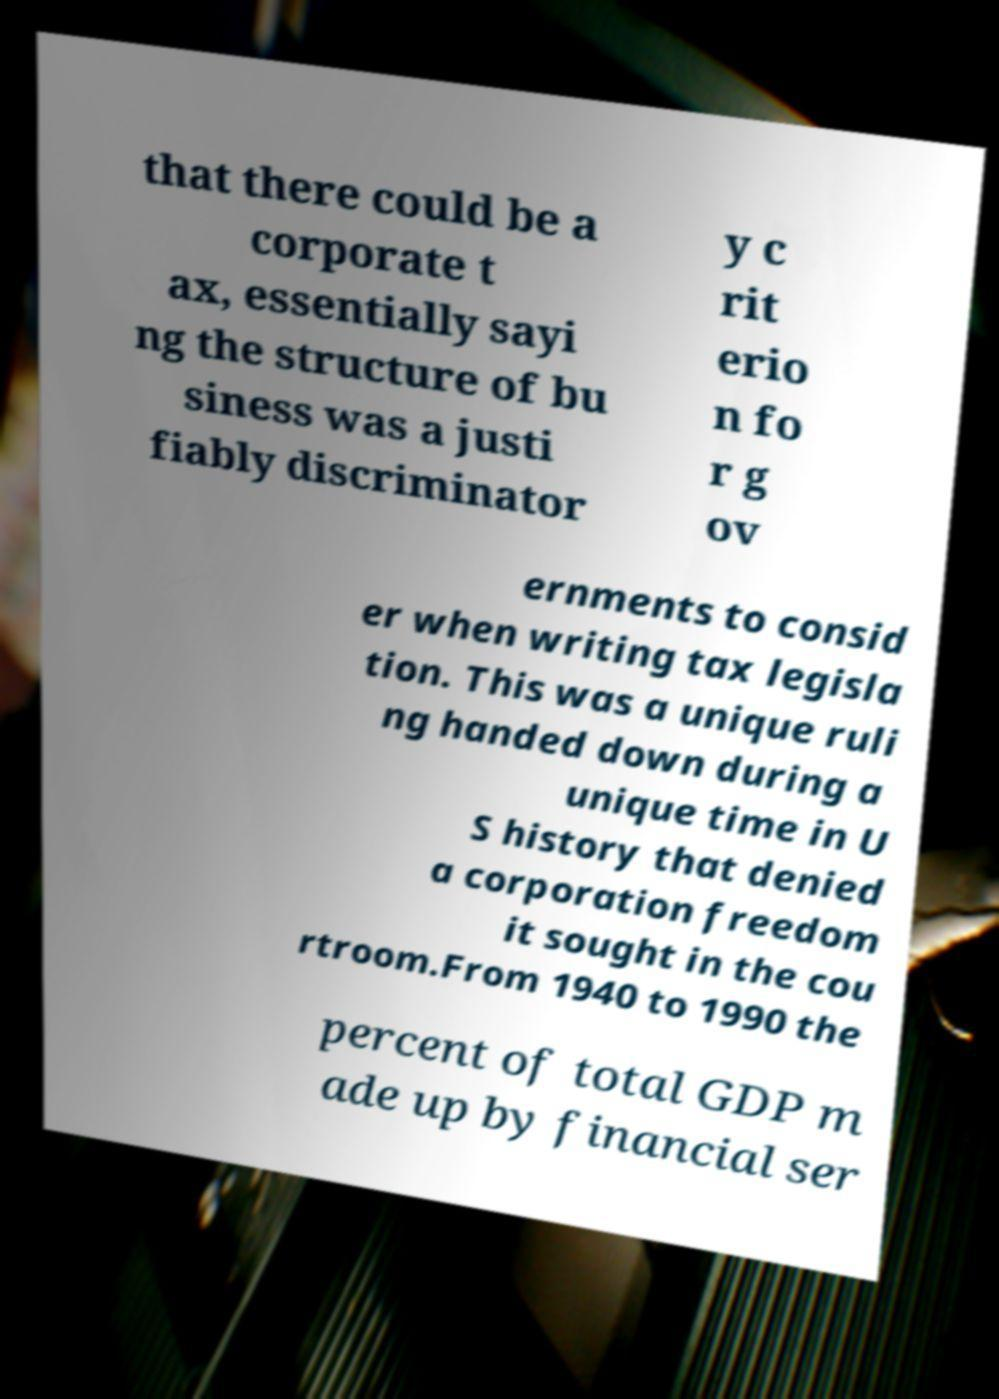What messages or text are displayed in this image? I need them in a readable, typed format. that there could be a corporate t ax, essentially sayi ng the structure of bu siness was a justi fiably discriminator y c rit erio n fo r g ov ernments to consid er when writing tax legisla tion. This was a unique ruli ng handed down during a unique time in U S history that denied a corporation freedom it sought in the cou rtroom.From 1940 to 1990 the percent of total GDP m ade up by financial ser 